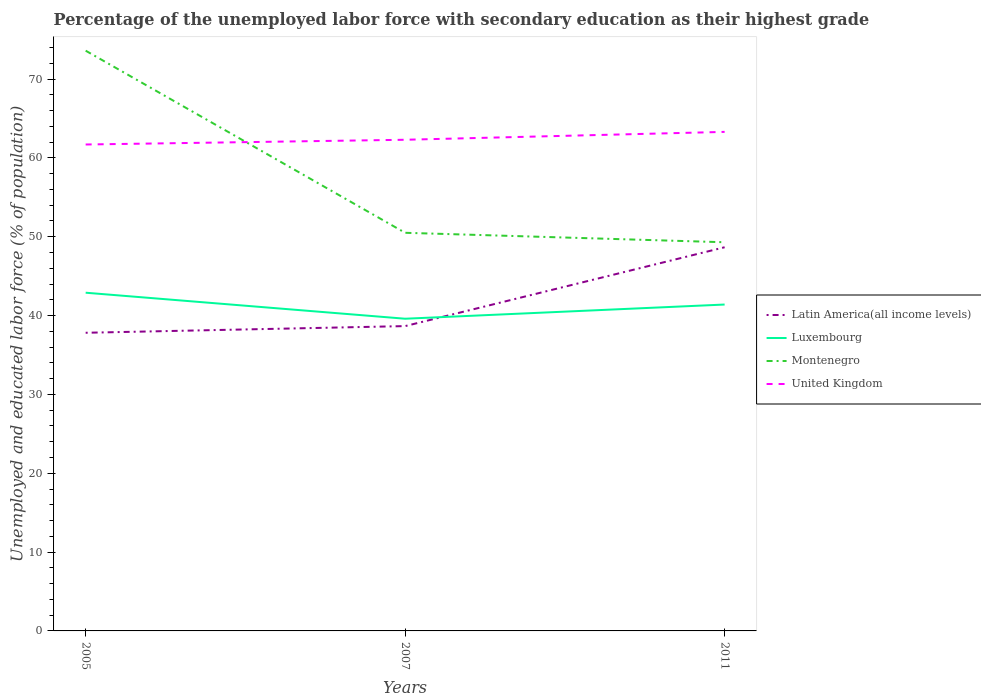How many different coloured lines are there?
Make the answer very short. 4. Is the number of lines equal to the number of legend labels?
Make the answer very short. Yes. Across all years, what is the maximum percentage of the unemployed labor force with secondary education in Montenegro?
Make the answer very short. 49.3. In which year was the percentage of the unemployed labor force with secondary education in United Kingdom maximum?
Provide a short and direct response. 2005. What is the total percentage of the unemployed labor force with secondary education in Latin America(all income levels) in the graph?
Provide a succinct answer. -10. What is the difference between the highest and the second highest percentage of the unemployed labor force with secondary education in Latin America(all income levels)?
Ensure brevity in your answer.  10.85. What is the difference between the highest and the lowest percentage of the unemployed labor force with secondary education in United Kingdom?
Make the answer very short. 1. Is the percentage of the unemployed labor force with secondary education in United Kingdom strictly greater than the percentage of the unemployed labor force with secondary education in Latin America(all income levels) over the years?
Ensure brevity in your answer.  No. What is the difference between two consecutive major ticks on the Y-axis?
Keep it short and to the point. 10. Are the values on the major ticks of Y-axis written in scientific E-notation?
Offer a very short reply. No. Does the graph contain any zero values?
Offer a terse response. No. Where does the legend appear in the graph?
Your answer should be compact. Center right. What is the title of the graph?
Your answer should be compact. Percentage of the unemployed labor force with secondary education as their highest grade. Does "Burkina Faso" appear as one of the legend labels in the graph?
Keep it short and to the point. No. What is the label or title of the Y-axis?
Offer a very short reply. Unemployed and educated labor force (% of population). What is the Unemployed and educated labor force (% of population) of Latin America(all income levels) in 2005?
Provide a short and direct response. 37.82. What is the Unemployed and educated labor force (% of population) of Luxembourg in 2005?
Ensure brevity in your answer.  42.9. What is the Unemployed and educated labor force (% of population) of Montenegro in 2005?
Offer a very short reply. 73.6. What is the Unemployed and educated labor force (% of population) of United Kingdom in 2005?
Make the answer very short. 61.7. What is the Unemployed and educated labor force (% of population) of Latin America(all income levels) in 2007?
Ensure brevity in your answer.  38.66. What is the Unemployed and educated labor force (% of population) in Luxembourg in 2007?
Provide a short and direct response. 39.6. What is the Unemployed and educated labor force (% of population) of Montenegro in 2007?
Keep it short and to the point. 50.5. What is the Unemployed and educated labor force (% of population) in United Kingdom in 2007?
Provide a succinct answer. 62.3. What is the Unemployed and educated labor force (% of population) in Latin America(all income levels) in 2011?
Keep it short and to the point. 48.67. What is the Unemployed and educated labor force (% of population) in Luxembourg in 2011?
Offer a terse response. 41.4. What is the Unemployed and educated labor force (% of population) of Montenegro in 2011?
Make the answer very short. 49.3. What is the Unemployed and educated labor force (% of population) of United Kingdom in 2011?
Provide a succinct answer. 63.3. Across all years, what is the maximum Unemployed and educated labor force (% of population) in Latin America(all income levels)?
Your answer should be compact. 48.67. Across all years, what is the maximum Unemployed and educated labor force (% of population) in Luxembourg?
Ensure brevity in your answer.  42.9. Across all years, what is the maximum Unemployed and educated labor force (% of population) in Montenegro?
Offer a terse response. 73.6. Across all years, what is the maximum Unemployed and educated labor force (% of population) of United Kingdom?
Keep it short and to the point. 63.3. Across all years, what is the minimum Unemployed and educated labor force (% of population) in Latin America(all income levels)?
Provide a short and direct response. 37.82. Across all years, what is the minimum Unemployed and educated labor force (% of population) in Luxembourg?
Offer a terse response. 39.6. Across all years, what is the minimum Unemployed and educated labor force (% of population) of Montenegro?
Your response must be concise. 49.3. Across all years, what is the minimum Unemployed and educated labor force (% of population) in United Kingdom?
Offer a terse response. 61.7. What is the total Unemployed and educated labor force (% of population) of Latin America(all income levels) in the graph?
Your answer should be compact. 125.15. What is the total Unemployed and educated labor force (% of population) in Luxembourg in the graph?
Provide a short and direct response. 123.9. What is the total Unemployed and educated labor force (% of population) of Montenegro in the graph?
Your answer should be very brief. 173.4. What is the total Unemployed and educated labor force (% of population) of United Kingdom in the graph?
Make the answer very short. 187.3. What is the difference between the Unemployed and educated labor force (% of population) in Latin America(all income levels) in 2005 and that in 2007?
Make the answer very short. -0.85. What is the difference between the Unemployed and educated labor force (% of population) in Montenegro in 2005 and that in 2007?
Your response must be concise. 23.1. What is the difference between the Unemployed and educated labor force (% of population) in United Kingdom in 2005 and that in 2007?
Ensure brevity in your answer.  -0.6. What is the difference between the Unemployed and educated labor force (% of population) of Latin America(all income levels) in 2005 and that in 2011?
Your answer should be compact. -10.85. What is the difference between the Unemployed and educated labor force (% of population) in Luxembourg in 2005 and that in 2011?
Ensure brevity in your answer.  1.5. What is the difference between the Unemployed and educated labor force (% of population) of Montenegro in 2005 and that in 2011?
Offer a terse response. 24.3. What is the difference between the Unemployed and educated labor force (% of population) of Latin America(all income levels) in 2007 and that in 2011?
Your answer should be compact. -10. What is the difference between the Unemployed and educated labor force (% of population) in Montenegro in 2007 and that in 2011?
Offer a terse response. 1.2. What is the difference between the Unemployed and educated labor force (% of population) in Latin America(all income levels) in 2005 and the Unemployed and educated labor force (% of population) in Luxembourg in 2007?
Your answer should be very brief. -1.78. What is the difference between the Unemployed and educated labor force (% of population) in Latin America(all income levels) in 2005 and the Unemployed and educated labor force (% of population) in Montenegro in 2007?
Keep it short and to the point. -12.68. What is the difference between the Unemployed and educated labor force (% of population) of Latin America(all income levels) in 2005 and the Unemployed and educated labor force (% of population) of United Kingdom in 2007?
Provide a short and direct response. -24.48. What is the difference between the Unemployed and educated labor force (% of population) of Luxembourg in 2005 and the Unemployed and educated labor force (% of population) of United Kingdom in 2007?
Your answer should be very brief. -19.4. What is the difference between the Unemployed and educated labor force (% of population) in Latin America(all income levels) in 2005 and the Unemployed and educated labor force (% of population) in Luxembourg in 2011?
Make the answer very short. -3.58. What is the difference between the Unemployed and educated labor force (% of population) in Latin America(all income levels) in 2005 and the Unemployed and educated labor force (% of population) in Montenegro in 2011?
Provide a short and direct response. -11.48. What is the difference between the Unemployed and educated labor force (% of population) in Latin America(all income levels) in 2005 and the Unemployed and educated labor force (% of population) in United Kingdom in 2011?
Your response must be concise. -25.48. What is the difference between the Unemployed and educated labor force (% of population) in Luxembourg in 2005 and the Unemployed and educated labor force (% of population) in United Kingdom in 2011?
Make the answer very short. -20.4. What is the difference between the Unemployed and educated labor force (% of population) of Montenegro in 2005 and the Unemployed and educated labor force (% of population) of United Kingdom in 2011?
Offer a very short reply. 10.3. What is the difference between the Unemployed and educated labor force (% of population) in Latin America(all income levels) in 2007 and the Unemployed and educated labor force (% of population) in Luxembourg in 2011?
Your answer should be compact. -2.74. What is the difference between the Unemployed and educated labor force (% of population) in Latin America(all income levels) in 2007 and the Unemployed and educated labor force (% of population) in Montenegro in 2011?
Your answer should be compact. -10.64. What is the difference between the Unemployed and educated labor force (% of population) of Latin America(all income levels) in 2007 and the Unemployed and educated labor force (% of population) of United Kingdom in 2011?
Offer a very short reply. -24.64. What is the difference between the Unemployed and educated labor force (% of population) in Luxembourg in 2007 and the Unemployed and educated labor force (% of population) in Montenegro in 2011?
Keep it short and to the point. -9.7. What is the difference between the Unemployed and educated labor force (% of population) in Luxembourg in 2007 and the Unemployed and educated labor force (% of population) in United Kingdom in 2011?
Keep it short and to the point. -23.7. What is the average Unemployed and educated labor force (% of population) in Latin America(all income levels) per year?
Your answer should be compact. 41.72. What is the average Unemployed and educated labor force (% of population) in Luxembourg per year?
Your answer should be very brief. 41.3. What is the average Unemployed and educated labor force (% of population) in Montenegro per year?
Provide a succinct answer. 57.8. What is the average Unemployed and educated labor force (% of population) of United Kingdom per year?
Offer a very short reply. 62.43. In the year 2005, what is the difference between the Unemployed and educated labor force (% of population) of Latin America(all income levels) and Unemployed and educated labor force (% of population) of Luxembourg?
Provide a short and direct response. -5.08. In the year 2005, what is the difference between the Unemployed and educated labor force (% of population) in Latin America(all income levels) and Unemployed and educated labor force (% of population) in Montenegro?
Offer a very short reply. -35.78. In the year 2005, what is the difference between the Unemployed and educated labor force (% of population) in Latin America(all income levels) and Unemployed and educated labor force (% of population) in United Kingdom?
Your response must be concise. -23.88. In the year 2005, what is the difference between the Unemployed and educated labor force (% of population) in Luxembourg and Unemployed and educated labor force (% of population) in Montenegro?
Keep it short and to the point. -30.7. In the year 2005, what is the difference between the Unemployed and educated labor force (% of population) of Luxembourg and Unemployed and educated labor force (% of population) of United Kingdom?
Your response must be concise. -18.8. In the year 2007, what is the difference between the Unemployed and educated labor force (% of population) in Latin America(all income levels) and Unemployed and educated labor force (% of population) in Luxembourg?
Make the answer very short. -0.94. In the year 2007, what is the difference between the Unemployed and educated labor force (% of population) in Latin America(all income levels) and Unemployed and educated labor force (% of population) in Montenegro?
Your answer should be very brief. -11.84. In the year 2007, what is the difference between the Unemployed and educated labor force (% of population) in Latin America(all income levels) and Unemployed and educated labor force (% of population) in United Kingdom?
Ensure brevity in your answer.  -23.64. In the year 2007, what is the difference between the Unemployed and educated labor force (% of population) in Luxembourg and Unemployed and educated labor force (% of population) in United Kingdom?
Offer a very short reply. -22.7. In the year 2007, what is the difference between the Unemployed and educated labor force (% of population) of Montenegro and Unemployed and educated labor force (% of population) of United Kingdom?
Your answer should be very brief. -11.8. In the year 2011, what is the difference between the Unemployed and educated labor force (% of population) in Latin America(all income levels) and Unemployed and educated labor force (% of population) in Luxembourg?
Offer a terse response. 7.27. In the year 2011, what is the difference between the Unemployed and educated labor force (% of population) of Latin America(all income levels) and Unemployed and educated labor force (% of population) of Montenegro?
Your answer should be very brief. -0.63. In the year 2011, what is the difference between the Unemployed and educated labor force (% of population) in Latin America(all income levels) and Unemployed and educated labor force (% of population) in United Kingdom?
Ensure brevity in your answer.  -14.63. In the year 2011, what is the difference between the Unemployed and educated labor force (% of population) of Luxembourg and Unemployed and educated labor force (% of population) of United Kingdom?
Give a very brief answer. -21.9. What is the ratio of the Unemployed and educated labor force (% of population) of Latin America(all income levels) in 2005 to that in 2007?
Your response must be concise. 0.98. What is the ratio of the Unemployed and educated labor force (% of population) in Montenegro in 2005 to that in 2007?
Make the answer very short. 1.46. What is the ratio of the Unemployed and educated labor force (% of population) of United Kingdom in 2005 to that in 2007?
Provide a short and direct response. 0.99. What is the ratio of the Unemployed and educated labor force (% of population) in Latin America(all income levels) in 2005 to that in 2011?
Provide a short and direct response. 0.78. What is the ratio of the Unemployed and educated labor force (% of population) of Luxembourg in 2005 to that in 2011?
Keep it short and to the point. 1.04. What is the ratio of the Unemployed and educated labor force (% of population) in Montenegro in 2005 to that in 2011?
Your answer should be compact. 1.49. What is the ratio of the Unemployed and educated labor force (% of population) of United Kingdom in 2005 to that in 2011?
Your answer should be compact. 0.97. What is the ratio of the Unemployed and educated labor force (% of population) in Latin America(all income levels) in 2007 to that in 2011?
Make the answer very short. 0.79. What is the ratio of the Unemployed and educated labor force (% of population) of Luxembourg in 2007 to that in 2011?
Your answer should be very brief. 0.96. What is the ratio of the Unemployed and educated labor force (% of population) in Montenegro in 2007 to that in 2011?
Ensure brevity in your answer.  1.02. What is the ratio of the Unemployed and educated labor force (% of population) of United Kingdom in 2007 to that in 2011?
Make the answer very short. 0.98. What is the difference between the highest and the second highest Unemployed and educated labor force (% of population) of Latin America(all income levels)?
Your response must be concise. 10. What is the difference between the highest and the second highest Unemployed and educated labor force (% of population) in Montenegro?
Your answer should be compact. 23.1. What is the difference between the highest and the second highest Unemployed and educated labor force (% of population) of United Kingdom?
Your answer should be very brief. 1. What is the difference between the highest and the lowest Unemployed and educated labor force (% of population) in Latin America(all income levels)?
Your answer should be very brief. 10.85. What is the difference between the highest and the lowest Unemployed and educated labor force (% of population) in Luxembourg?
Keep it short and to the point. 3.3. What is the difference between the highest and the lowest Unemployed and educated labor force (% of population) in Montenegro?
Your response must be concise. 24.3. 